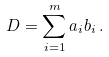Convert formula to latex. <formula><loc_0><loc_0><loc_500><loc_500>D = \sum _ { i = 1 } ^ { m } a _ { i } b _ { i } \, .</formula> 